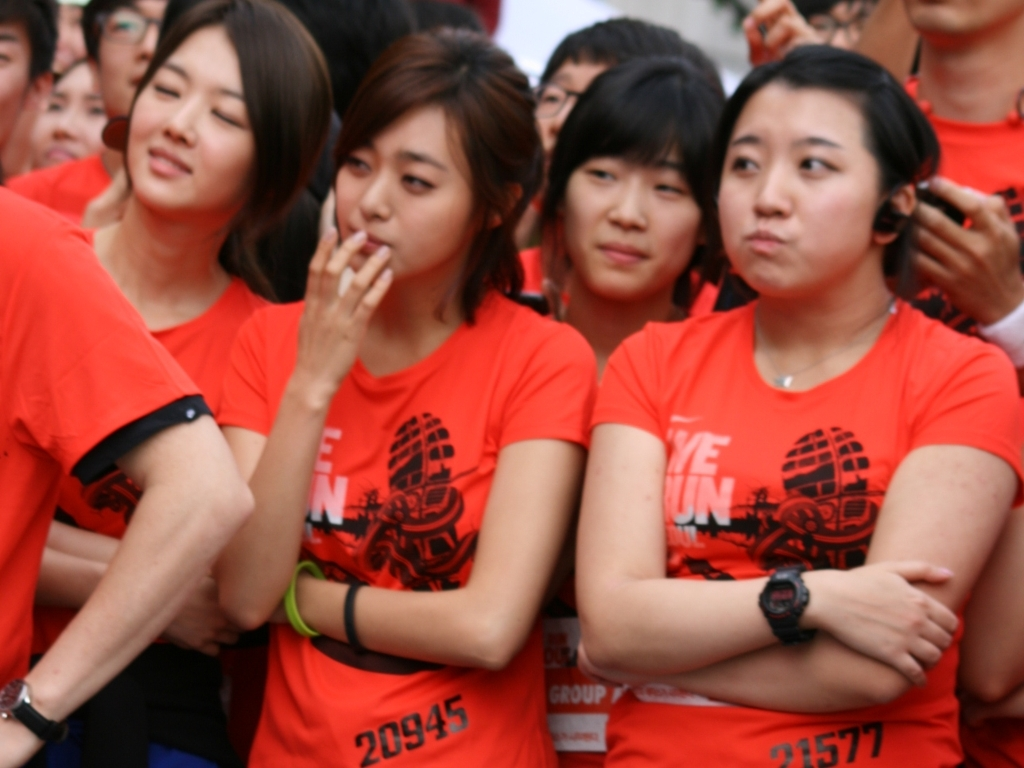How do the participants' accessories contribute to understanding the context of the image? Many participants are wearing wristbands and sports watches, which are common accessories for runners and athletes to monitor performance or keep track of time during an event. They add to the perception that this is a sporting event. Moreover, the fact that no one is dressed in heavy sporting gear (beside the watches) could imply that this is a more approachable, amateur event rather than a high-competition scenario. 